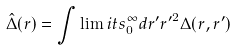<formula> <loc_0><loc_0><loc_500><loc_500>\hat { \Delta } ( r ) = \int \lim i t s _ { 0 } ^ { \infty } d r ^ { \prime } { r ^ { \prime } } ^ { 2 } \Delta ( r , r ^ { \prime } )</formula> 